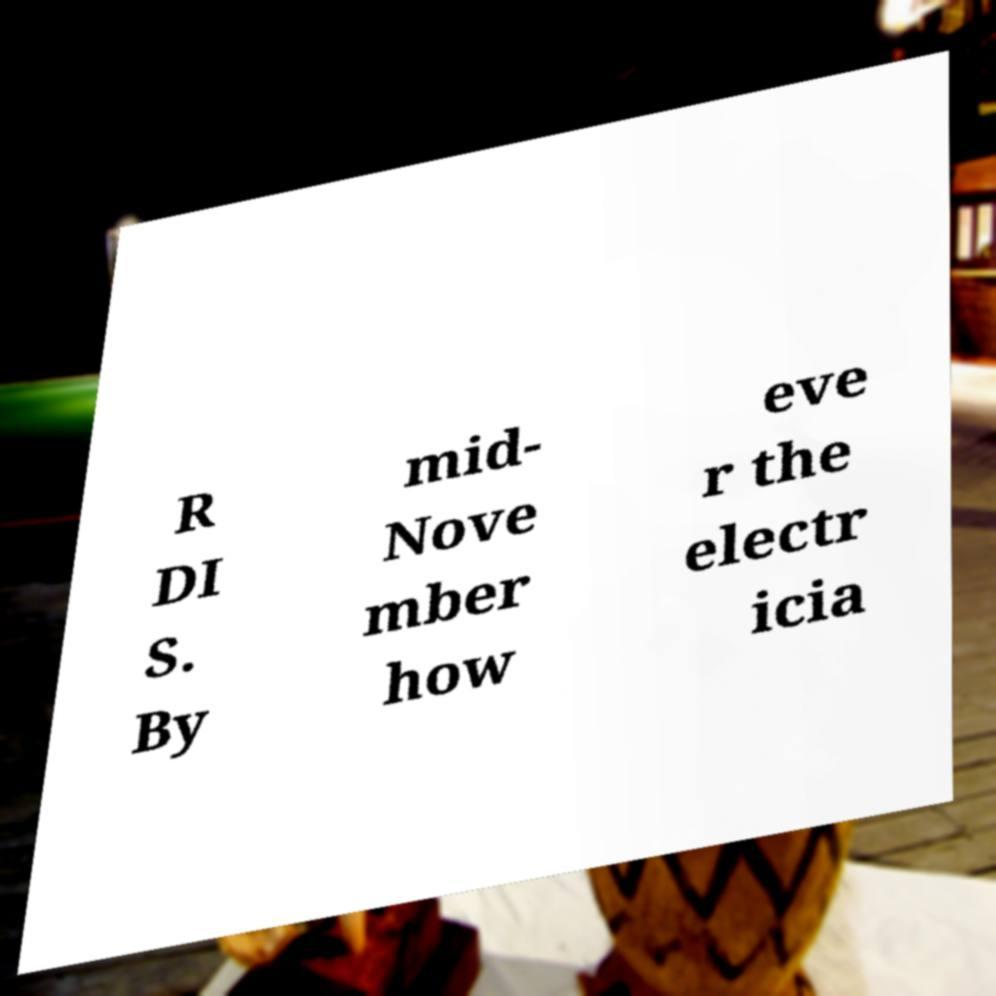Can you accurately transcribe the text from the provided image for me? R DI S. By mid- Nove mber how eve r the electr icia 